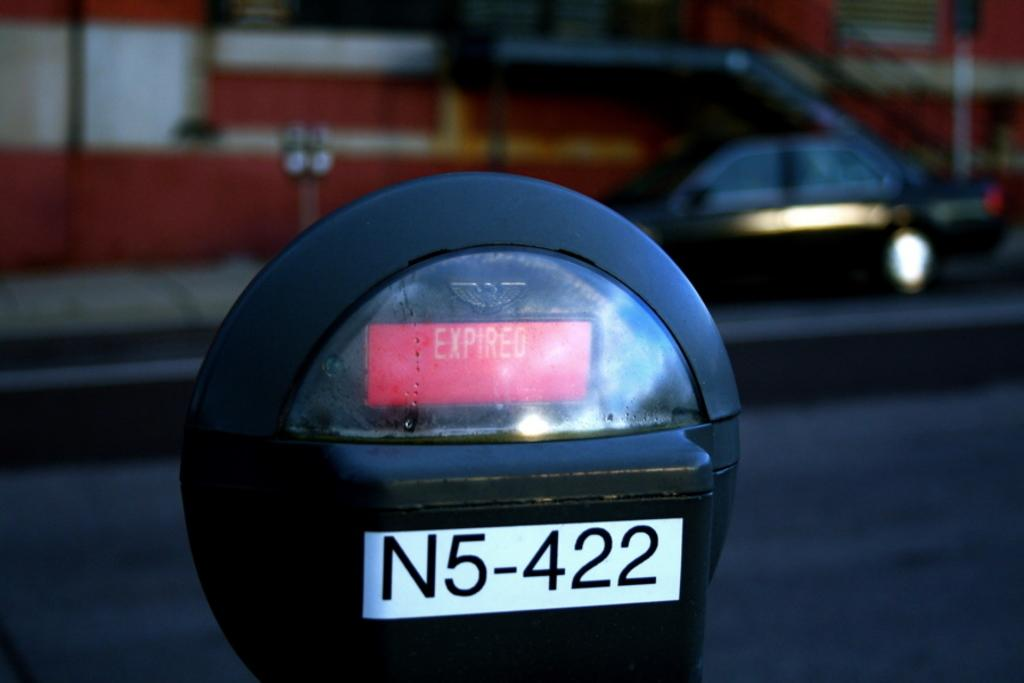<image>
Provide a brief description of the given image. a parking meter reads EXPIRED over serial number N5-422 